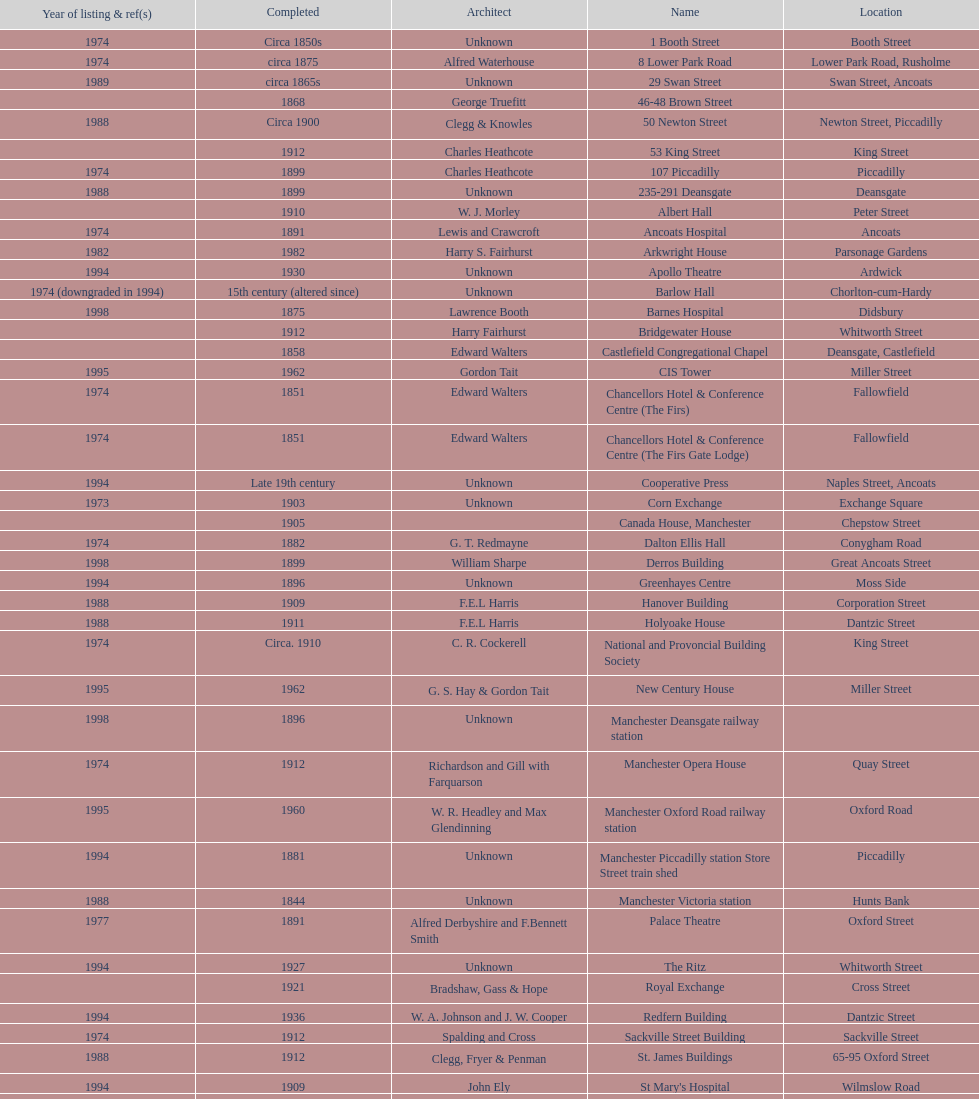Which year has the most buildings listed? 1974. 